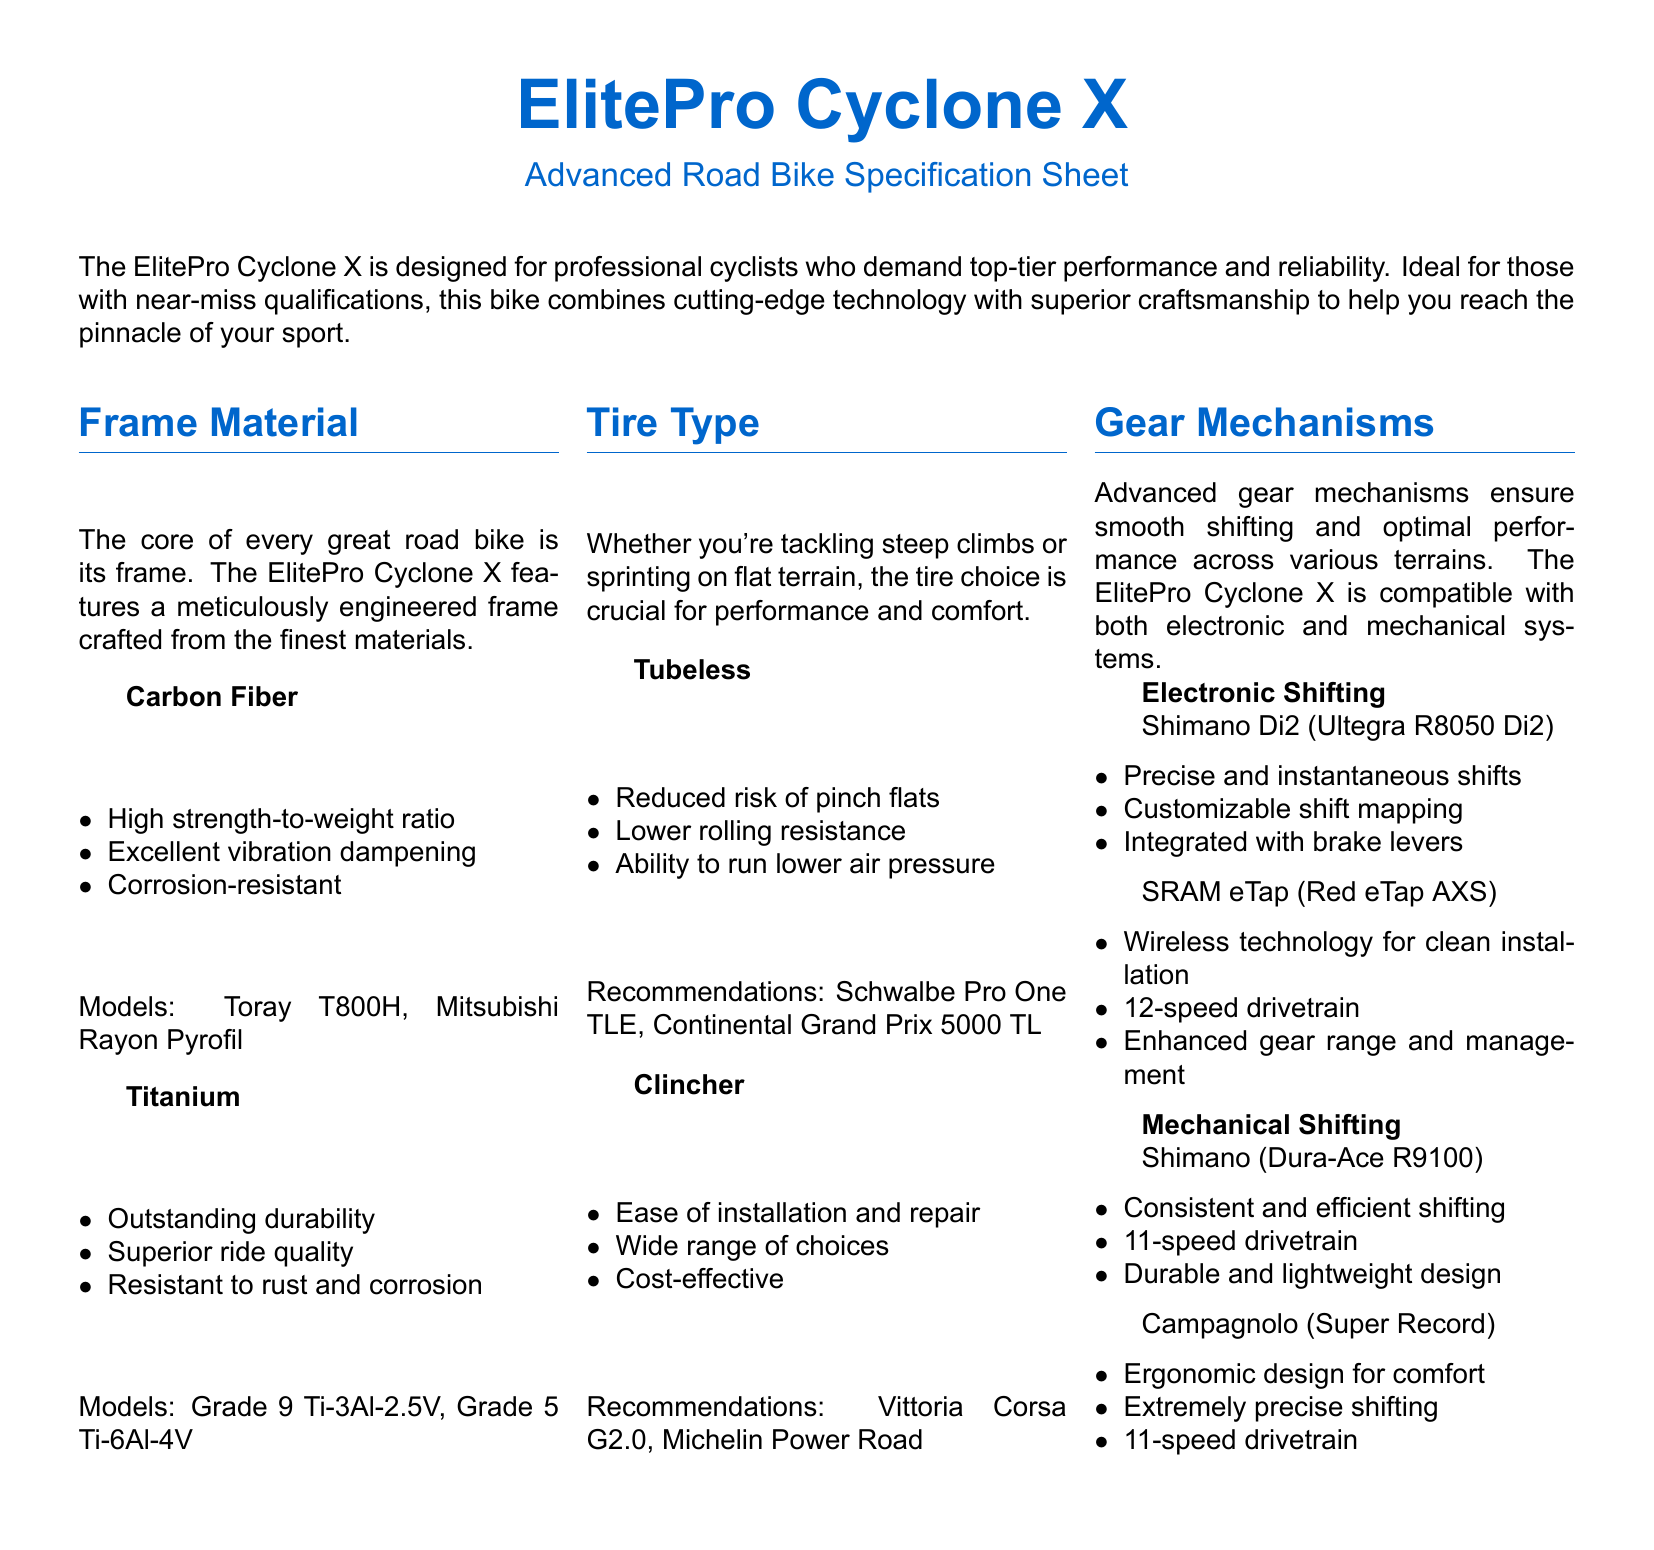What materials are used in the frame? The frame is crafted from either carbon fiber or titanium.
Answer: Carbon Fiber, Titanium What is a key feature of carbon fiber? A key feature of carbon fiber is its high strength-to-weight ratio.
Answer: High strength-to-weight ratio What tire type reduces the risk of pinch flats? The tire type that reduces the risk of pinch flats is tubeless.
Answer: Tubeless What is one recommendation for clincher tires? One recommendation for clincher tires is the Vittoria Corsa G2.0.
Answer: Vittoria Corsa G2.0 Which electronic shifting system is mentioned? The electronic shifting system mentioned is Shimano Di2.
Answer: Shimano Di2 How many speeds does the Shimano Dura-Ace R9100 have? The Shimano Dura-Ace R9100 has 11 speeds.
Answer: 11-speed What advantage does SRAM eTap have? An advantage of SRAM eTap is its wireless technology for clean installation.
Answer: Wireless technology What type of document is this? This document is a product specification sheet.
Answer: Product specification sheet 